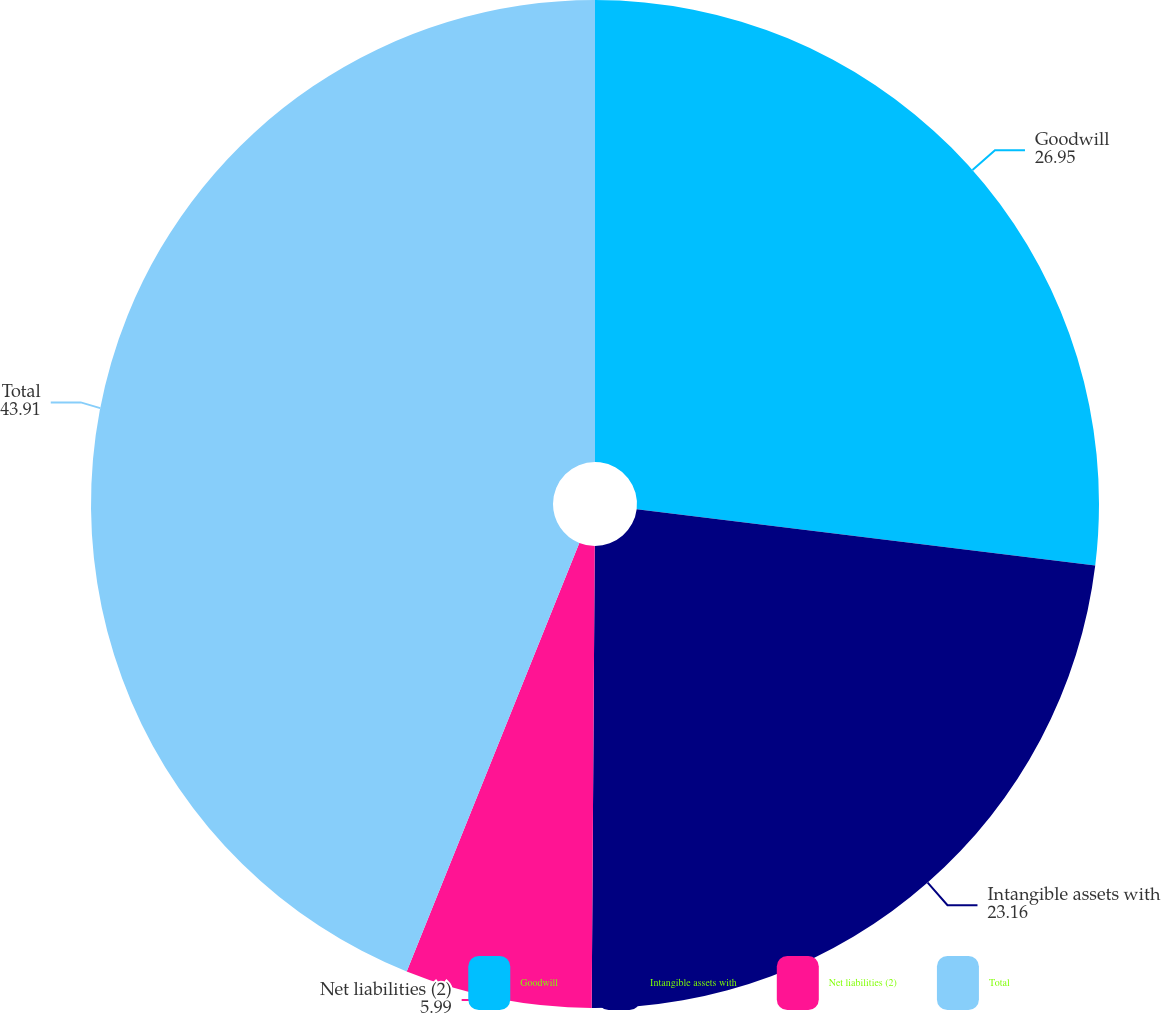Convert chart to OTSL. <chart><loc_0><loc_0><loc_500><loc_500><pie_chart><fcel>Goodwill<fcel>Intangible assets with<fcel>Net liabilities (2)<fcel>Total<nl><fcel>26.95%<fcel>23.16%<fcel>5.99%<fcel>43.91%<nl></chart> 